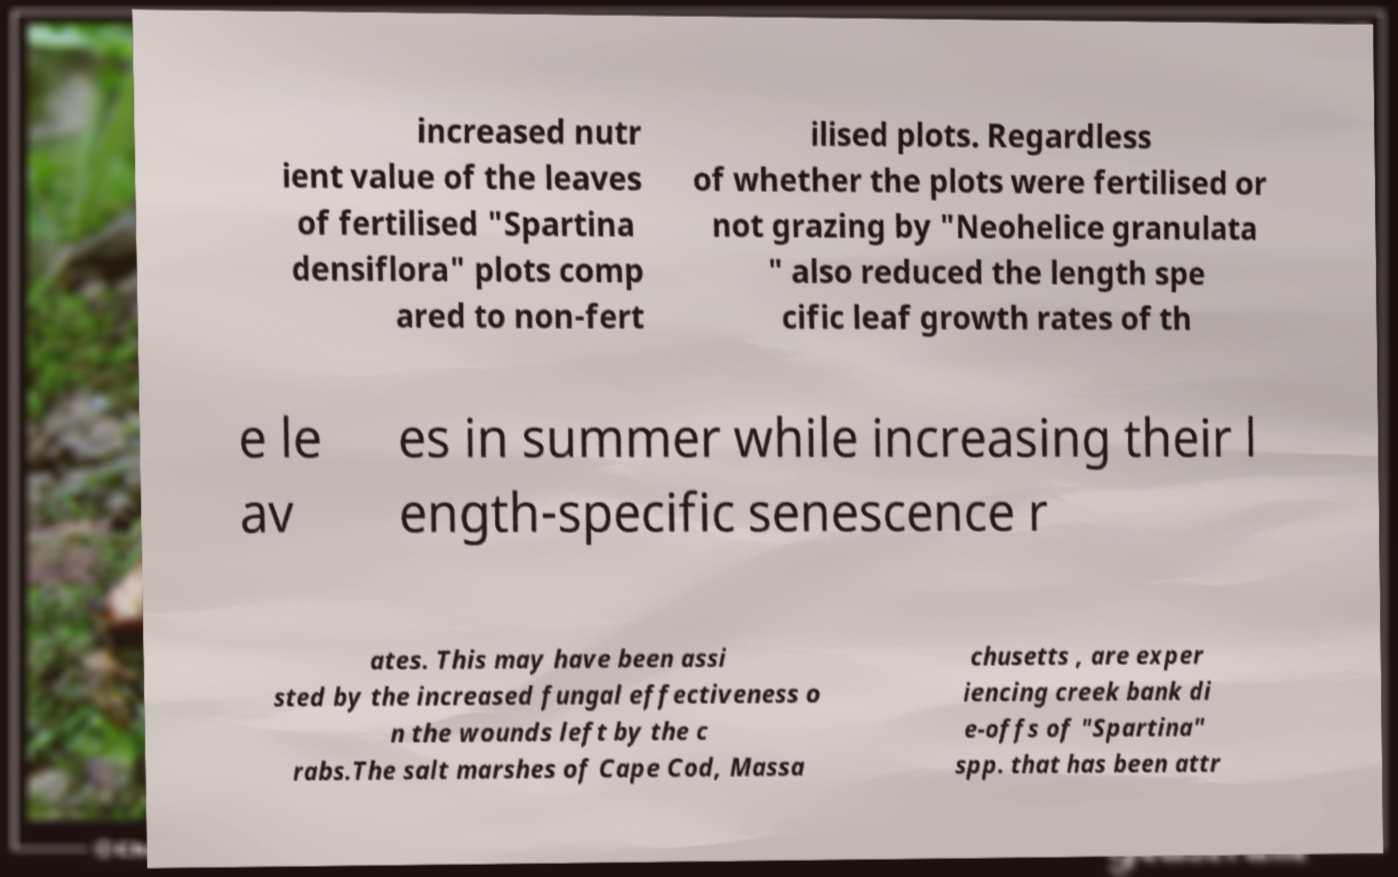Could you assist in decoding the text presented in this image and type it out clearly? increased nutr ient value of the leaves of fertilised "Spartina densiflora" plots comp ared to non-fert ilised plots. Regardless of whether the plots were fertilised or not grazing by "Neohelice granulata " also reduced the length spe cific leaf growth rates of th e le av es in summer while increasing their l ength-specific senescence r ates. This may have been assi sted by the increased fungal effectiveness o n the wounds left by the c rabs.The salt marshes of Cape Cod, Massa chusetts , are exper iencing creek bank di e-offs of "Spartina" spp. that has been attr 